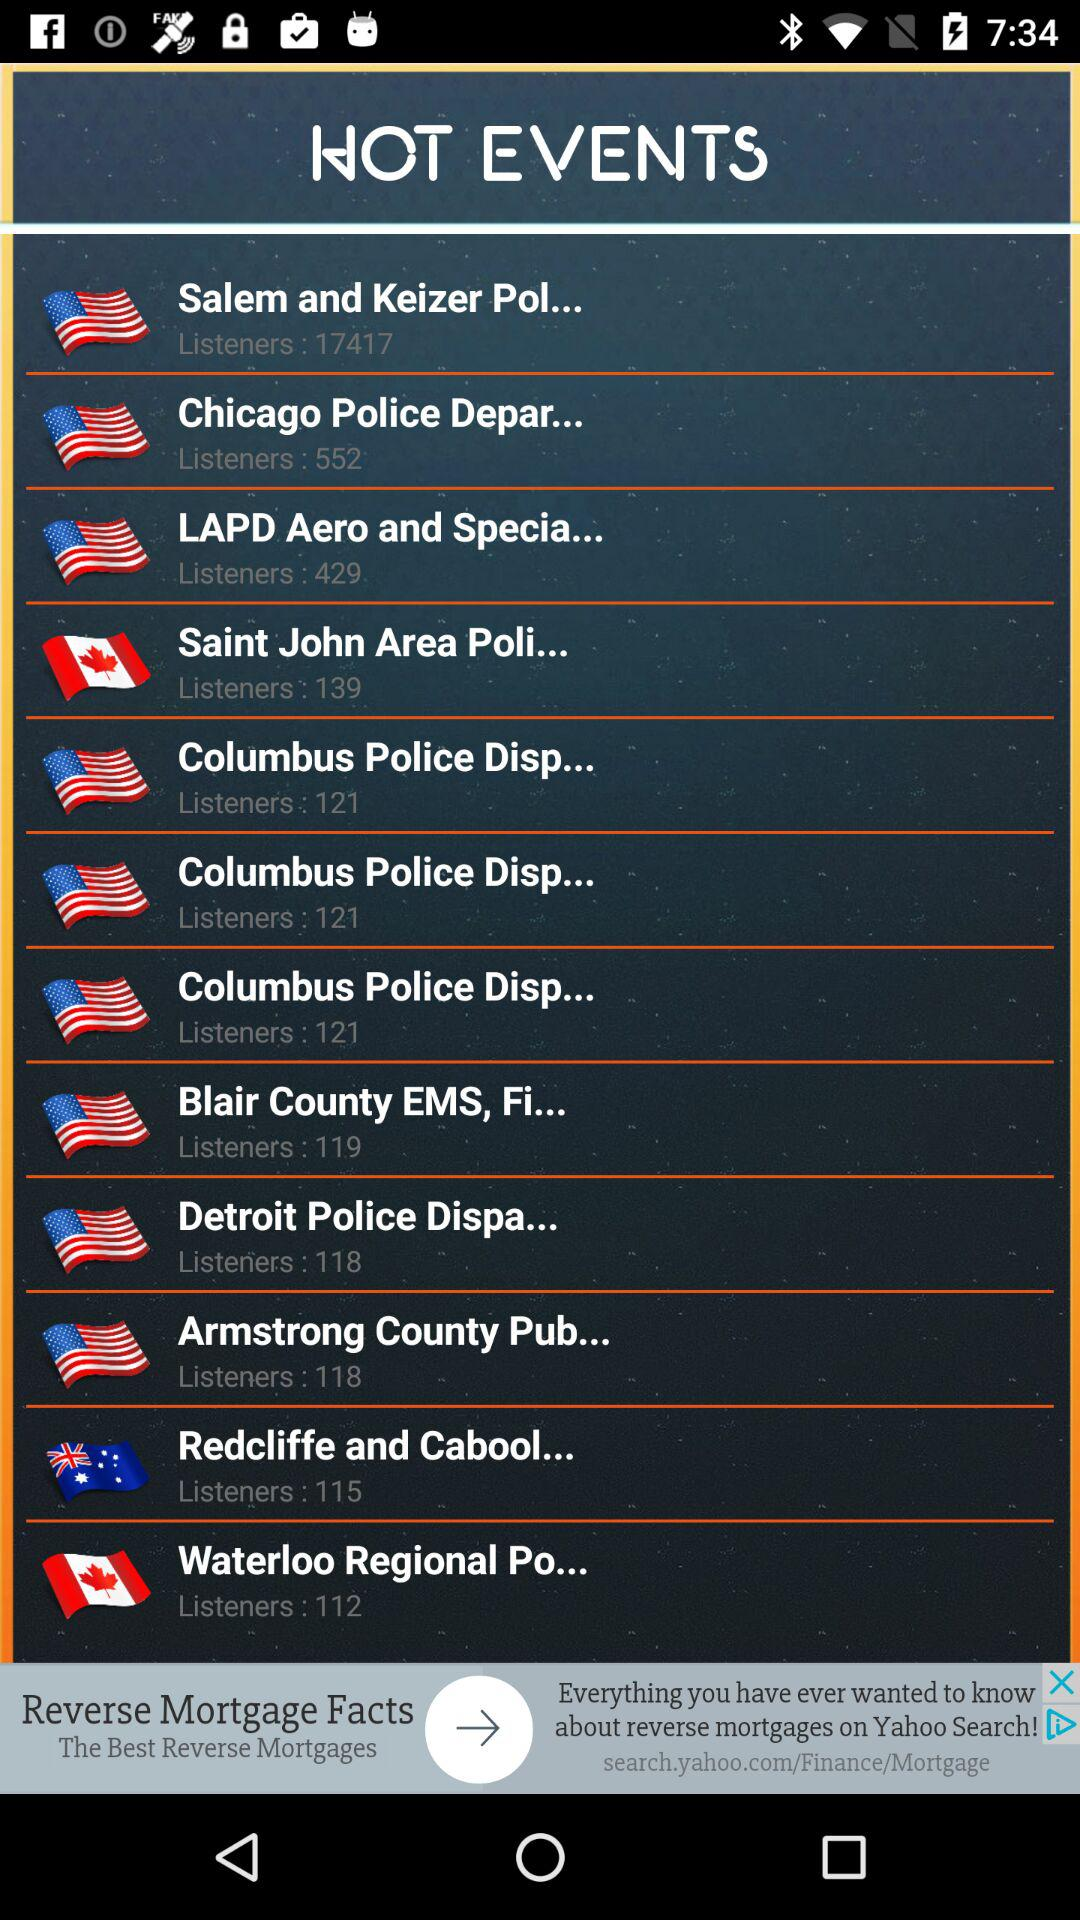Which events have 119 listeners? The event is "Blair Country EMS, Fi...". 